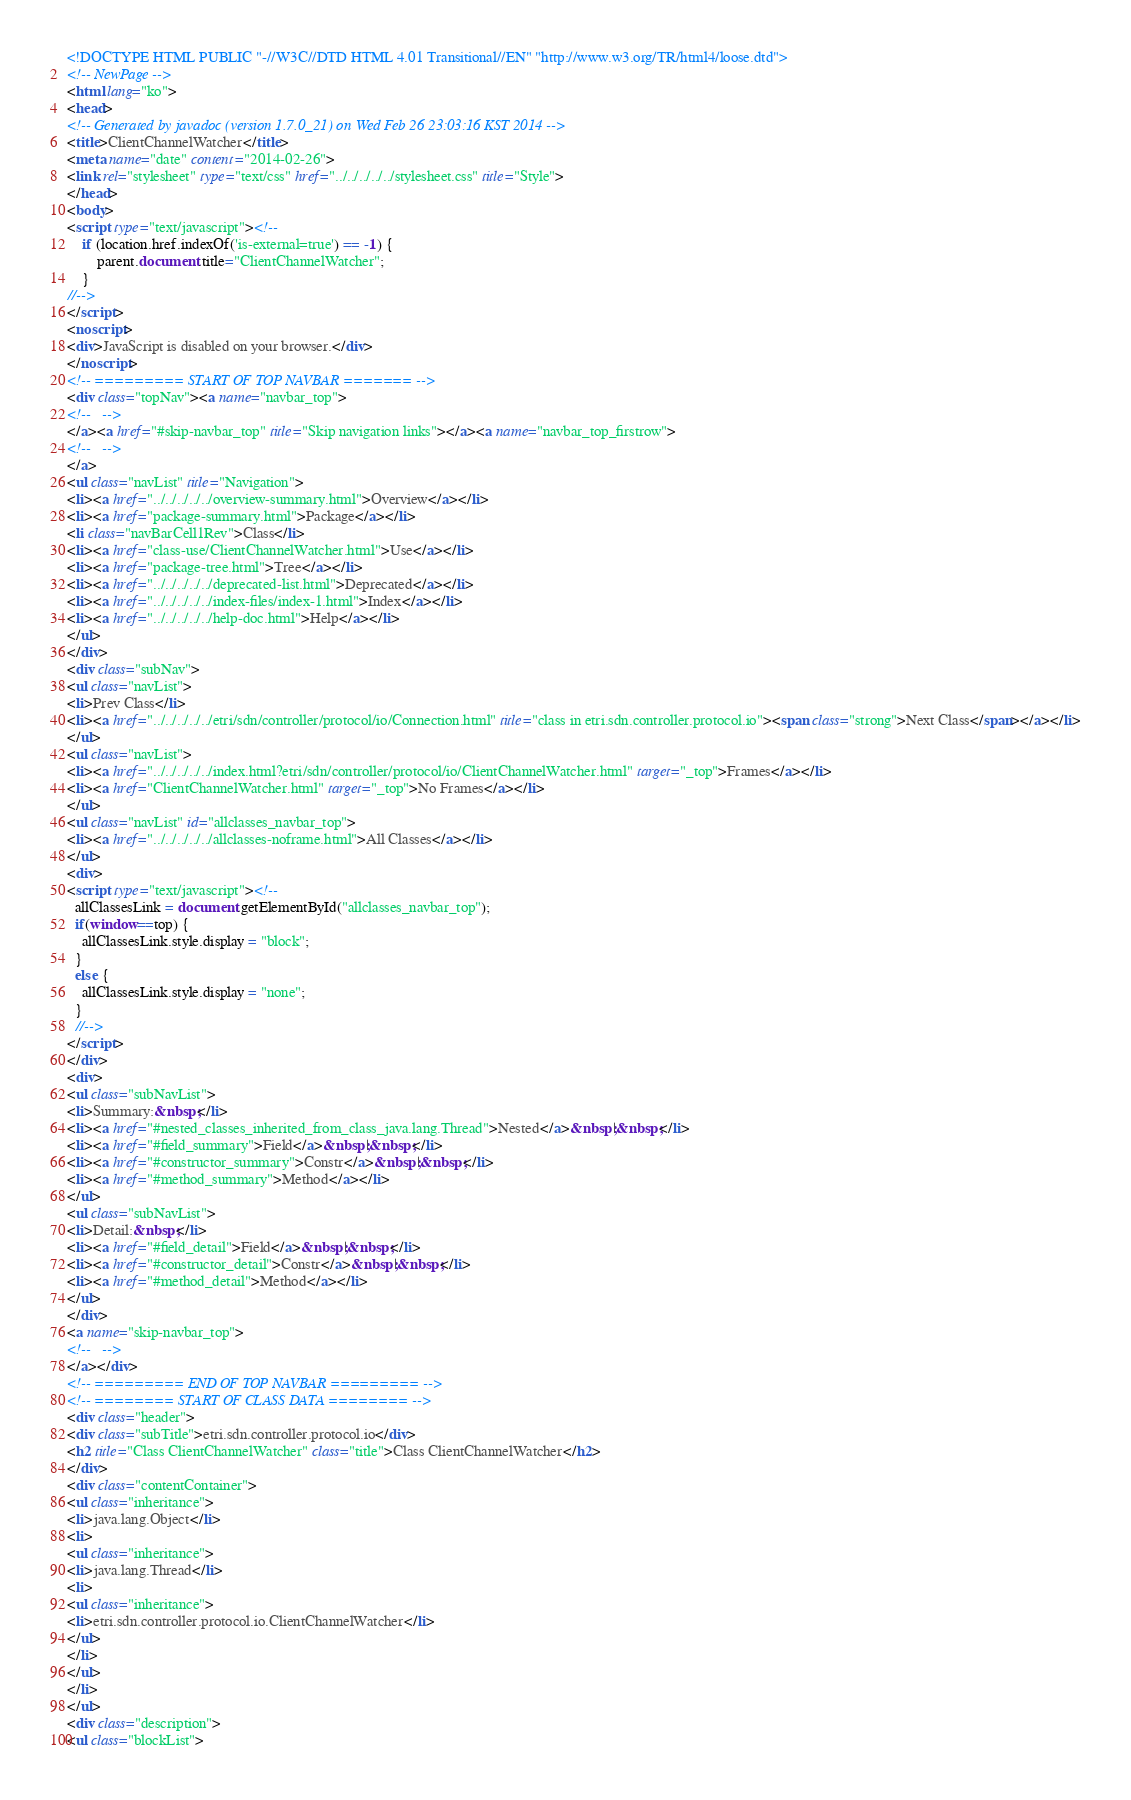Convert code to text. <code><loc_0><loc_0><loc_500><loc_500><_HTML_><!DOCTYPE HTML PUBLIC "-//W3C//DTD HTML 4.01 Transitional//EN" "http://www.w3.org/TR/html4/loose.dtd">
<!-- NewPage -->
<html lang="ko">
<head>
<!-- Generated by javadoc (version 1.7.0_21) on Wed Feb 26 23:03:16 KST 2014 -->
<title>ClientChannelWatcher</title>
<meta name="date" content="2014-02-26">
<link rel="stylesheet" type="text/css" href="../../../../../stylesheet.css" title="Style">
</head>
<body>
<script type="text/javascript"><!--
    if (location.href.indexOf('is-external=true') == -1) {
        parent.document.title="ClientChannelWatcher";
    }
//-->
</script>
<noscript>
<div>JavaScript is disabled on your browser.</div>
</noscript>
<!-- ========= START OF TOP NAVBAR ======= -->
<div class="topNav"><a name="navbar_top">
<!--   -->
</a><a href="#skip-navbar_top" title="Skip navigation links"></a><a name="navbar_top_firstrow">
<!--   -->
</a>
<ul class="navList" title="Navigation">
<li><a href="../../../../../overview-summary.html">Overview</a></li>
<li><a href="package-summary.html">Package</a></li>
<li class="navBarCell1Rev">Class</li>
<li><a href="class-use/ClientChannelWatcher.html">Use</a></li>
<li><a href="package-tree.html">Tree</a></li>
<li><a href="../../../../../deprecated-list.html">Deprecated</a></li>
<li><a href="../../../../../index-files/index-1.html">Index</a></li>
<li><a href="../../../../../help-doc.html">Help</a></li>
</ul>
</div>
<div class="subNav">
<ul class="navList">
<li>Prev Class</li>
<li><a href="../../../../../etri/sdn/controller/protocol/io/Connection.html" title="class in etri.sdn.controller.protocol.io"><span class="strong">Next Class</span></a></li>
</ul>
<ul class="navList">
<li><a href="../../../../../index.html?etri/sdn/controller/protocol/io/ClientChannelWatcher.html" target="_top">Frames</a></li>
<li><a href="ClientChannelWatcher.html" target="_top">No Frames</a></li>
</ul>
<ul class="navList" id="allclasses_navbar_top">
<li><a href="../../../../../allclasses-noframe.html">All Classes</a></li>
</ul>
<div>
<script type="text/javascript"><!--
  allClassesLink = document.getElementById("allclasses_navbar_top");
  if(window==top) {
    allClassesLink.style.display = "block";
  }
  else {
    allClassesLink.style.display = "none";
  }
  //-->
</script>
</div>
<div>
<ul class="subNavList">
<li>Summary:&nbsp;</li>
<li><a href="#nested_classes_inherited_from_class_java.lang.Thread">Nested</a>&nbsp;|&nbsp;</li>
<li><a href="#field_summary">Field</a>&nbsp;|&nbsp;</li>
<li><a href="#constructor_summary">Constr</a>&nbsp;|&nbsp;</li>
<li><a href="#method_summary">Method</a></li>
</ul>
<ul class="subNavList">
<li>Detail:&nbsp;</li>
<li><a href="#field_detail">Field</a>&nbsp;|&nbsp;</li>
<li><a href="#constructor_detail">Constr</a>&nbsp;|&nbsp;</li>
<li><a href="#method_detail">Method</a></li>
</ul>
</div>
<a name="skip-navbar_top">
<!--   -->
</a></div>
<!-- ========= END OF TOP NAVBAR ========= -->
<!-- ======== START OF CLASS DATA ======== -->
<div class="header">
<div class="subTitle">etri.sdn.controller.protocol.io</div>
<h2 title="Class ClientChannelWatcher" class="title">Class ClientChannelWatcher</h2>
</div>
<div class="contentContainer">
<ul class="inheritance">
<li>java.lang.Object</li>
<li>
<ul class="inheritance">
<li>java.lang.Thread</li>
<li>
<ul class="inheritance">
<li>etri.sdn.controller.protocol.io.ClientChannelWatcher</li>
</ul>
</li>
</ul>
</li>
</ul>
<div class="description">
<ul class="blockList"></code> 